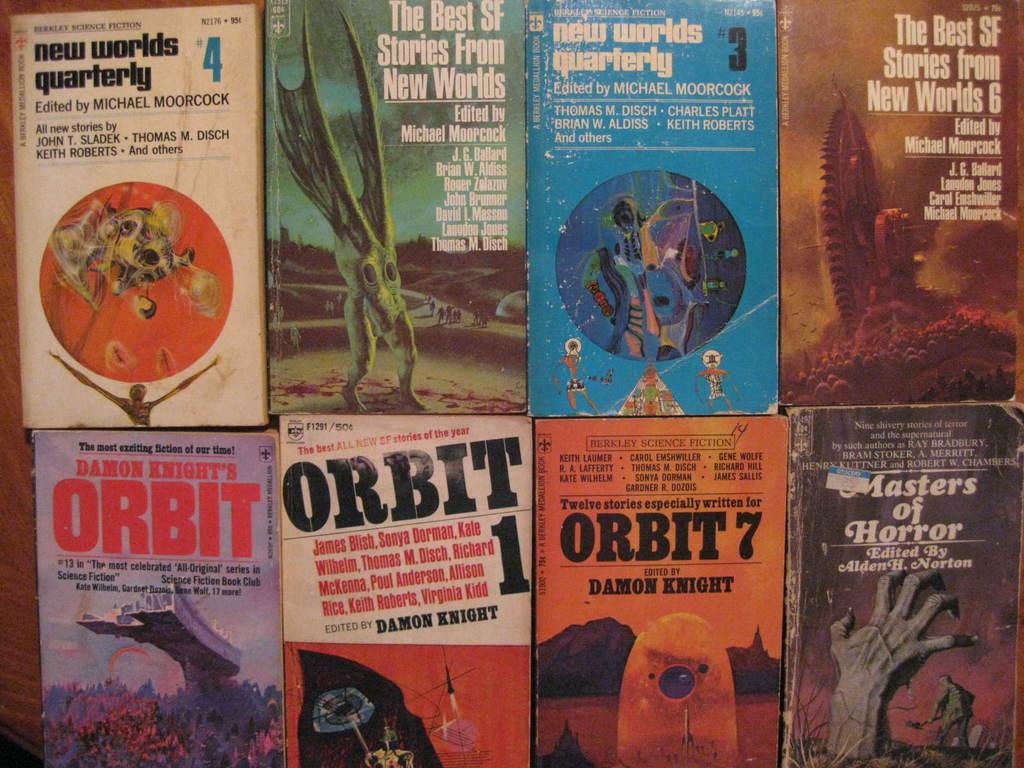<image>
Render a clear and concise summary of the photo. Eight books with the word Orbit in them 